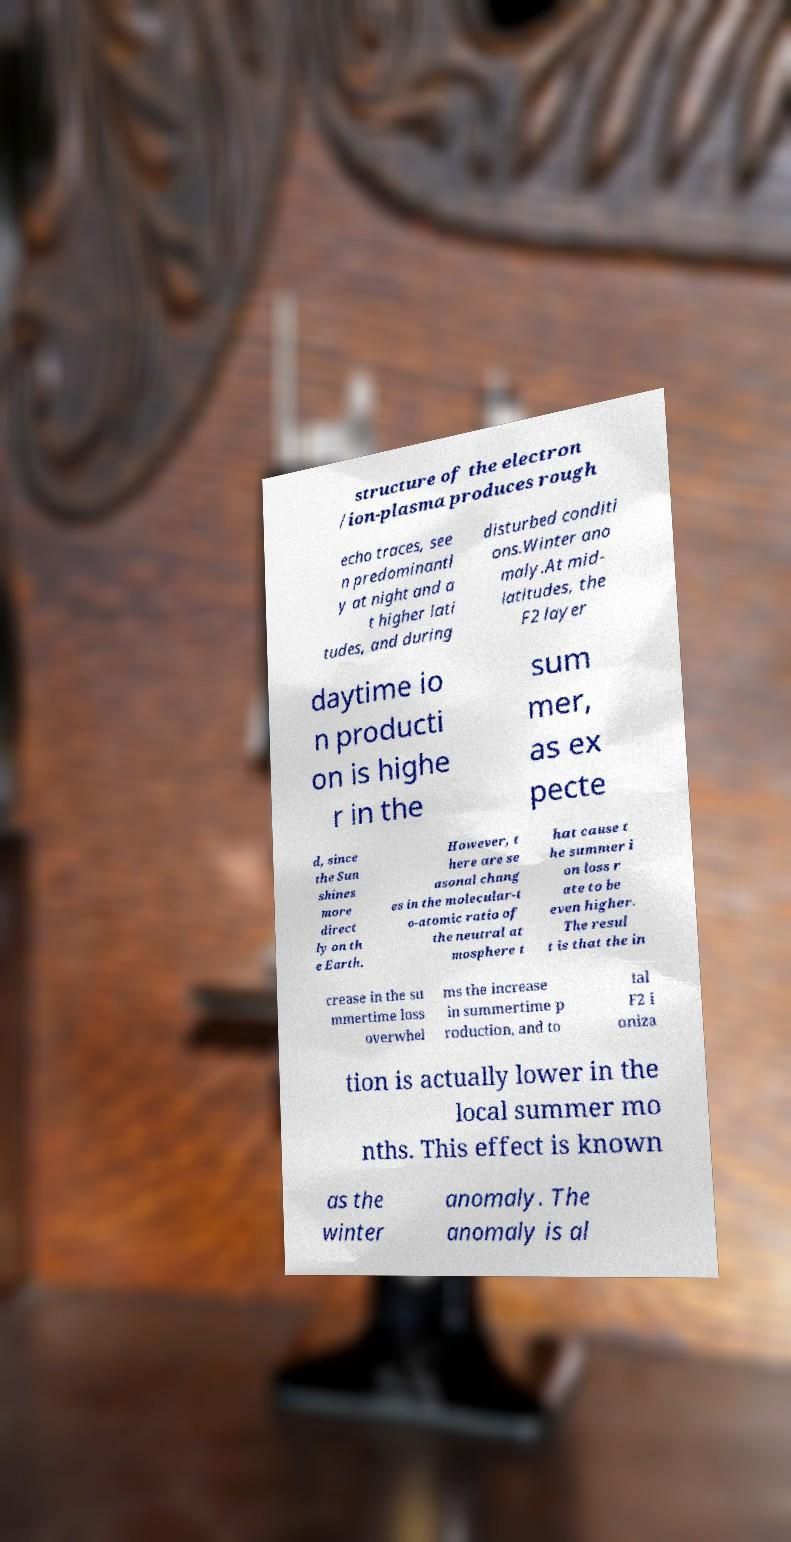For documentation purposes, I need the text within this image transcribed. Could you provide that? structure of the electron /ion-plasma produces rough echo traces, see n predominantl y at night and a t higher lati tudes, and during disturbed conditi ons.Winter ano maly.At mid- latitudes, the F2 layer daytime io n producti on is highe r in the sum mer, as ex pecte d, since the Sun shines more direct ly on th e Earth. However, t here are se asonal chang es in the molecular-t o-atomic ratio of the neutral at mosphere t hat cause t he summer i on loss r ate to be even higher. The resul t is that the in crease in the su mmertime loss overwhel ms the increase in summertime p roduction, and to tal F2 i oniza tion is actually lower in the local summer mo nths. This effect is known as the winter anomaly. The anomaly is al 